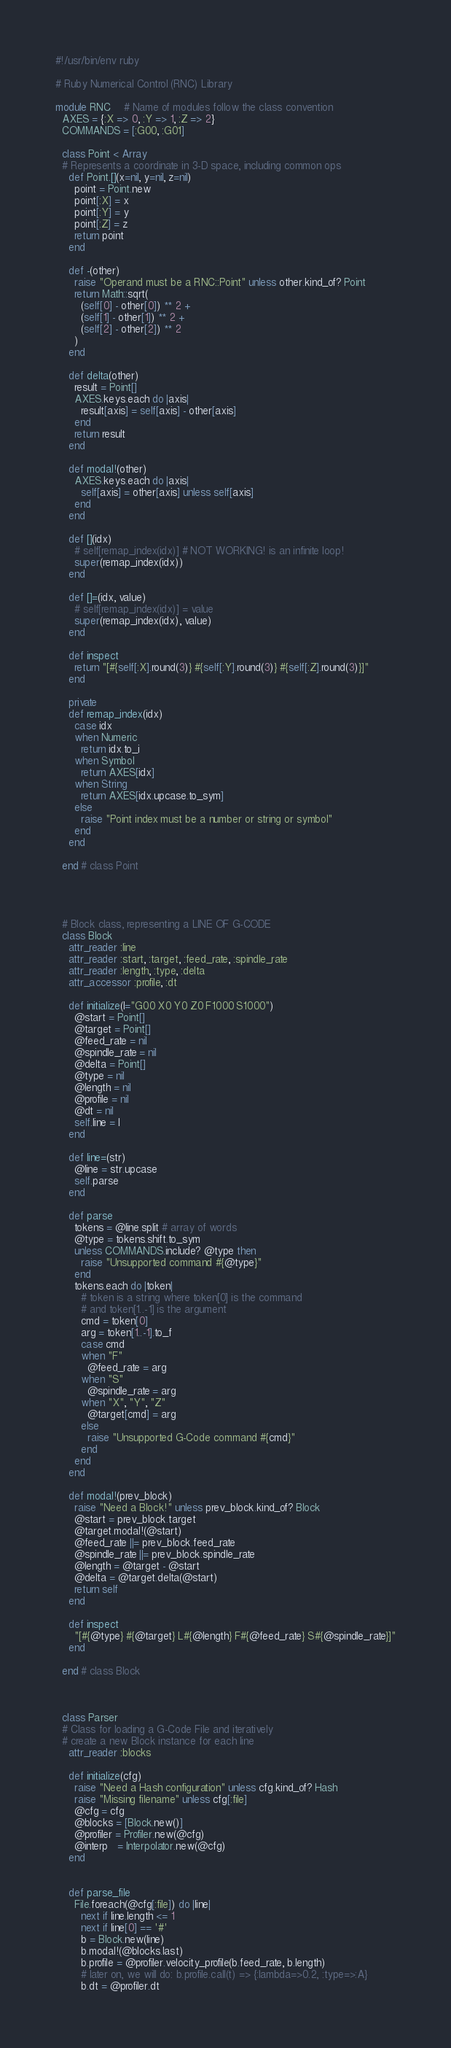Convert code to text. <code><loc_0><loc_0><loc_500><loc_500><_Ruby_>#!/usr/bin/env ruby

# Ruby Numerical Control (RNC) Library

module RNC    # Name of modules follow the class convention
  AXES = {:X => 0, :Y => 1, :Z => 2}
  COMMANDS = [:G00, :G01]
  
  class Point < Array
  # Represents a coordinate in 3-D space, including common ops
    def Point.[](x=nil, y=nil, z=nil)
      point = Point.new
      point[:X] = x
      point[:Y] = y
      point[:Z] = z
      return point
    end
  
    def -(other)
      raise "Operand must be a RNC::Point" unless other.kind_of? Point
      return Math::sqrt(
        (self[0] - other[0]) ** 2 +
        (self[1] - other[1]) ** 2 +
        (self[2] - other[2]) ** 2
      )
    end
    
    def delta(other)
      result = Point[]
      AXES.keys.each do |axis|
        result[axis] = self[axis] - other[axis]
      end
      return result
    end
    
    def modal!(other)
      AXES.keys.each do |axis|
        self[axis] = other[axis] unless self[axis]
      end
    end
    
    def [](idx)
      # self[remap_index(idx)] # NOT WORKING! is an infinite loop!
      super(remap_index(idx))
    end
    
    def []=(idx, value)
      # self[remap_index(idx)] = value
      super(remap_index(idx), value)
    end
    
    def inspect
      return "[#{self[:X].round(3)} #{self[:Y].round(3)} #{self[:Z].round(3)}]"
    end
    
    private
    def remap_index(idx)
      case idx
      when Numeric
        return idx.to_i
      when Symbol
        return AXES[idx]
      when String
        return AXES[idx.upcase.to_sym]
      else
        raise "Point index must be a number or string or symbol"
      end
    end

  end # class Point
  
  
  
  
  # Block class, representing a LINE OF G-CODE
  class Block
    attr_reader :line
    attr_reader :start, :target, :feed_rate, :spindle_rate
    attr_reader :length, :type, :delta
    attr_accessor :profile, :dt
    
    def initialize(l="G00 X0 Y0 Z0 F1000 S1000")
      @start = Point[]
      @target = Point[]
      @feed_rate = nil
      @spindle_rate = nil
      @delta = Point[]
      @type = nil
      @length = nil
      @profile = nil
      @dt = nil
      self.line = l
    end
    
    def line=(str)
      @line = str.upcase
      self.parse
    end
    
    def parse
      tokens = @line.split # array of words
      @type = tokens.shift.to_sym
      unless COMMANDS.include? @type then
        raise "Unsupported command #{@type}"
      end
      tokens.each do |token|
        # token is a string where token[0] is the command
        # and token[1..-1] is the argument
        cmd = token[0]
        arg = token[1..-1].to_f
        case cmd
        when "F"
          @feed_rate = arg
        when "S"
          @spindle_rate = arg
        when "X", "Y", "Z"
          @target[cmd] = arg
        else
          raise "Unsupported G-Code command #{cmd}"
        end
      end
    end
    
    def modal!(prev_block)
      raise "Need a Block!" unless prev_block.kind_of? Block
      @start = prev_block.target
      @target.modal!(@start)
      @feed_rate ||= prev_block.feed_rate
      @spindle_rate ||= prev_block.spindle_rate
      @length = @target - @start
      @delta = @target.delta(@start)
      return self
    end
    
    def inspect
      "[#{@type} #{@target} L#{@length} F#{@feed_rate} S#{@spindle_rate}]"
    end
  
  end # class Block
  
  
  
  class Parser
  # Class for loading a G-Code File and iteratively
  # create a new Block instance for each line
    attr_reader :blocks
  
    def initialize(cfg)
      raise "Need a Hash configuration" unless cfg.kind_of? Hash
      raise "Missing filename" unless cfg[:file]
      @cfg = cfg
      @blocks = [Block.new()]
      @profiler = Profiler.new(@cfg)
      @interp   = Interpolator.new(@cfg)
    end
  
  
    def parse_file
      File.foreach(@cfg[:file]) do |line|
        next if line.length <= 1
        next if line[0] == '#'
        b = Block.new(line)
        b.modal!(@blocks.last)
        b.profile = @profiler.velocity_profile(b.feed_rate, b.length)
        # later on, we will do: b.profile.call(t) => {:lambda=>0.2, :type=>:A}
        b.dt = @profiler.dt </code> 